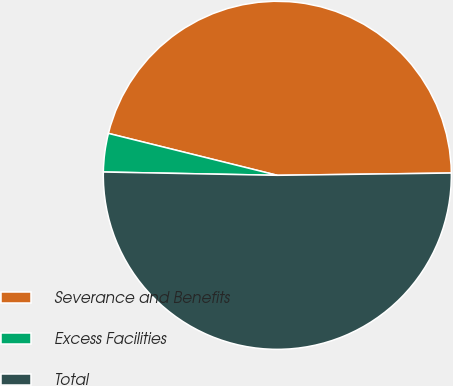Convert chart. <chart><loc_0><loc_0><loc_500><loc_500><pie_chart><fcel>Severance and Benefits<fcel>Excess Facilities<fcel>Total<nl><fcel>45.92%<fcel>3.57%<fcel>50.51%<nl></chart> 